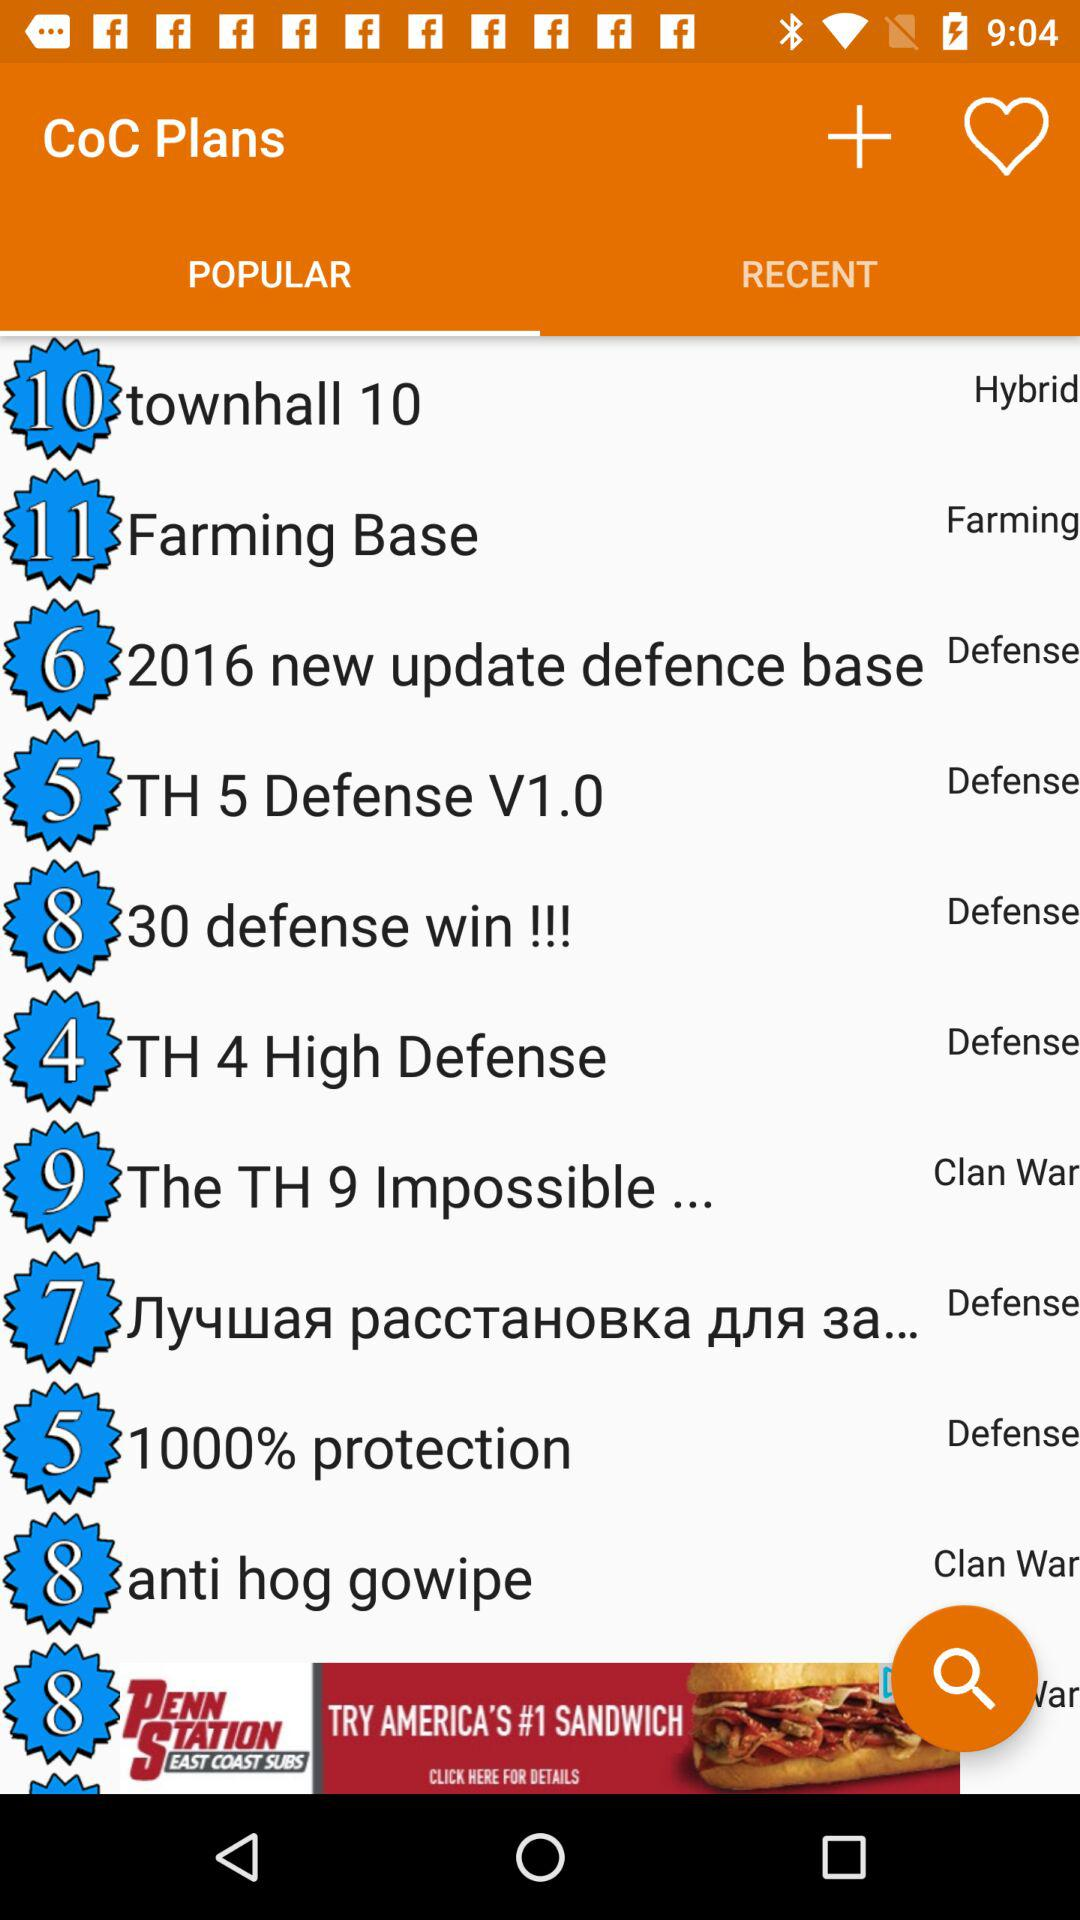Which tab has been selected? The selected tab is "POPULAR". 